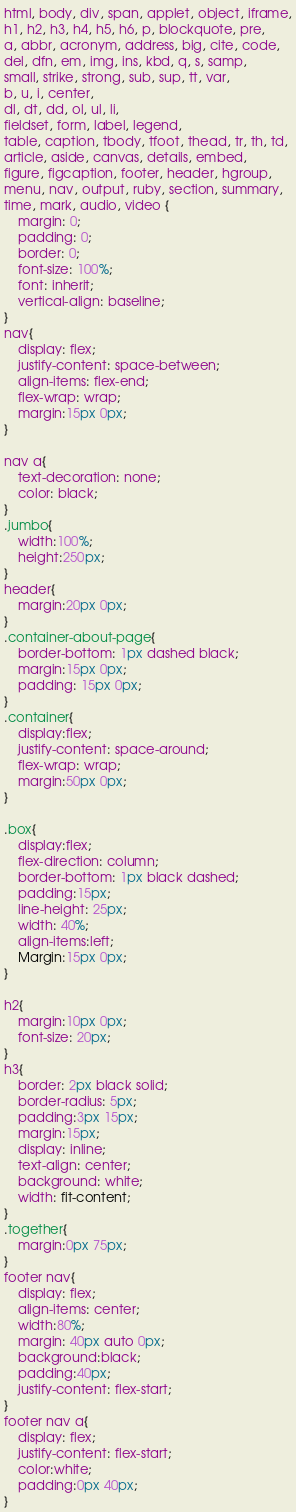Convert code to text. <code><loc_0><loc_0><loc_500><loc_500><_CSS_>html, body, div, span, applet, object, iframe,
h1, h2, h3, h4, h5, h6, p, blockquote, pre,
a, abbr, acronym, address, big, cite, code,
del, dfn, em, img, ins, kbd, q, s, samp,
small, strike, strong, sub, sup, tt, var,
b, u, i, center,
dl, dt, dd, ol, ul, li,
fieldset, form, label, legend,
table, caption, tbody, tfoot, thead, tr, th, td,
article, aside, canvas, details, embed, 
figure, figcaption, footer, header, hgroup, 
menu, nav, output, ruby, section, summary,
time, mark, audio, video {
	margin: 0;
	padding: 0;
	border: 0;
	font-size: 100%;
	font: inherit;
	vertical-align: baseline;
}
nav{
    display: flex;
    justify-content: space-between;
    align-items: flex-end;
    flex-wrap: wrap;
    margin:15px 0px;
}

nav a{
    text-decoration: none;
    color: black;
}
.jumbo{
    width:100%;
    height:250px;
}
header{
    margin:20px 0px;
}
.container-about-page{
    border-bottom: 1px dashed black;
    margin:15px 0px;
    padding: 15px 0px;
}
.container{
    display:flex;
    justify-content: space-around;
    flex-wrap: wrap;
    margin:50px 0px;
}

.box{
    display:flex;
    flex-direction: column;
    border-bottom: 1px black dashed;
    padding:15px;
    line-height: 25px;
    width: 40%;
    align-items:left;
    Margin:15px 0px; 
}

h2{
    margin:10px 0px;
    font-size: 20px;
}
h3{
    border: 2px black solid;
    border-radius: 5px;
    padding:3px 15px;
    margin:15px;
    display: inline;
    text-align: center;
    background: white;
    width: fit-content;
}
.together{
    margin:0px 75px;
}
footer nav{
    display: flex;
    align-items: center;
    width:80%;
    margin: 40px auto 0px;
    background:black;
    padding:40px;
    justify-content: flex-start;
}
footer nav a{
    display: flex;
    justify-content: flex-start;
    color:white;
    padding:0px 40px;
}
</code> 